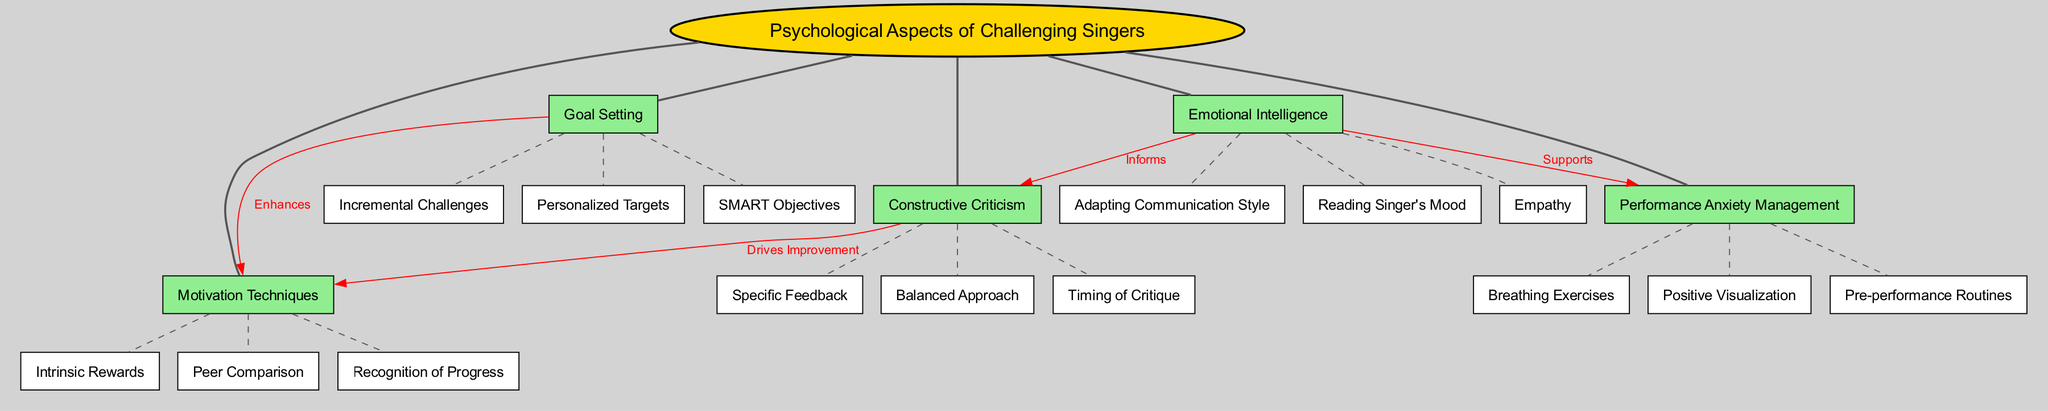What is the central concept of the diagram? The diagram's central concept is clearly labeled as "Psychological Aspects of Challenging Singers," which is the starting point of the concept map.
Answer: Psychological Aspects of Challenging Singers How many main nodes are present in the diagram? The diagram lists five main nodes branching from the central concept, each representing key psychological aspects. Counting these main nodes gives the total of five.
Answer: 5 What connects "Constructive Criticism" and "Motivation Techniques"? The diagram shows a red arrow from "Constructive Criticism" to "Motivation Techniques" labeled "Drives Improvement," which indicates a direct relationship between these two nodes.
Answer: Drives Improvement Which main node supports "Performance Anxiety Management"? The diagram connects "Emotional Intelligence" to "Performance Anxiety Management" with a labeled edge indicating that emotional intelligence is a supporting factor.
Answer: Emotional Intelligence What type of targets are mentioned under "Goal Setting"? The sub-node list under "Goal Setting" includes "SMART Objectives," which is a type of target that is mentioned within the context of goal setting in the diagram.
Answer: SMART Objectives How does "Goal Setting" enhance "Motivation Techniques"? The diagram specifies a connection from "Goal Setting" to "Motivation Techniques" labeled "Enhances," which describes how effective goal-setting can boost motivation strategies.
Answer: Enhances What is one of the sub-nodes under "Performance Anxiety Management"? The diagram lists several sub-nodes under the main node "Performance Anxiety Management," one of which is "Breathing Exercises," indicating a strategy for managing performance anxiety.
Answer: Breathing Exercises How many connections are there between main nodes in the diagram? The diagram indicates four distinct connections between the main nodes, each illustrating a different relationship based on the psychological aspects involved in motivating singers.
Answer: 4 Which sub-node is associated with "Balanced Approach"? The diagram lists "Balanced Approach" as a sub-node under "Constructive Criticism," indicating it is part of the broader concept of providing constructive criticism to singers.
Answer: Balanced Approach 